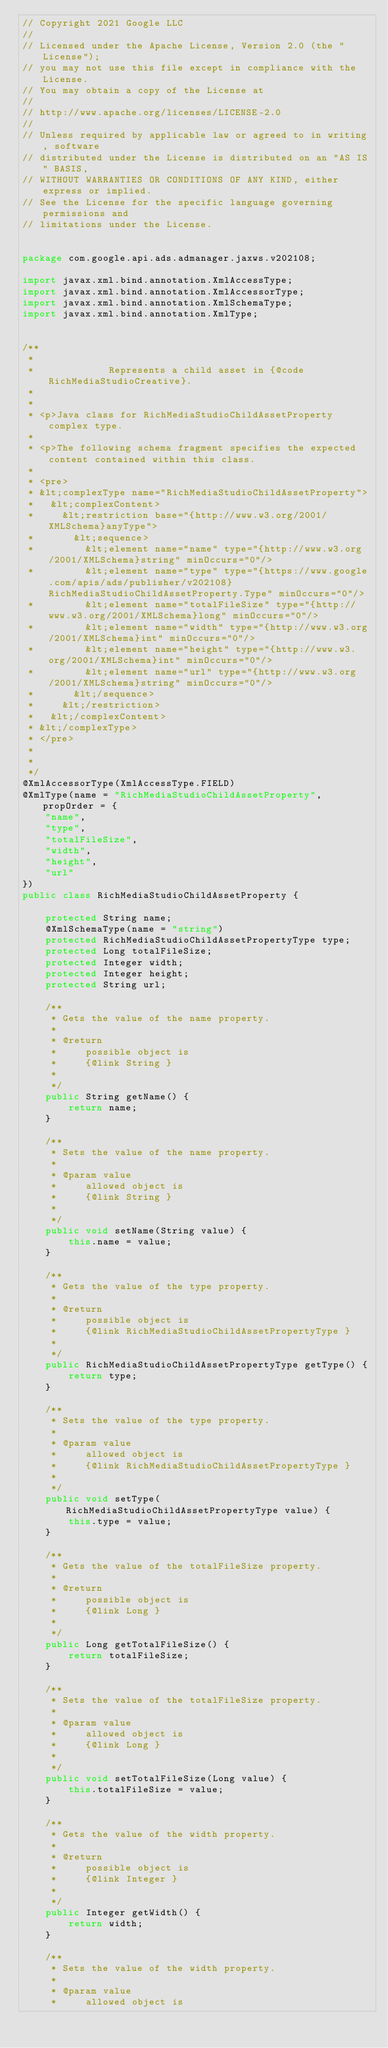Convert code to text. <code><loc_0><loc_0><loc_500><loc_500><_Java_>// Copyright 2021 Google LLC
//
// Licensed under the Apache License, Version 2.0 (the "License");
// you may not use this file except in compliance with the License.
// You may obtain a copy of the License at
//
// http://www.apache.org/licenses/LICENSE-2.0
//
// Unless required by applicable law or agreed to in writing, software
// distributed under the License is distributed on an "AS IS" BASIS,
// WITHOUT WARRANTIES OR CONDITIONS OF ANY KIND, either express or implied.
// See the License for the specific language governing permissions and
// limitations under the License.


package com.google.api.ads.admanager.jaxws.v202108;

import javax.xml.bind.annotation.XmlAccessType;
import javax.xml.bind.annotation.XmlAccessorType;
import javax.xml.bind.annotation.XmlSchemaType;
import javax.xml.bind.annotation.XmlType;


/**
 * 
 *             Represents a child asset in {@code RichMediaStudioCreative}.
 *           
 * 
 * <p>Java class for RichMediaStudioChildAssetProperty complex type.
 * 
 * <p>The following schema fragment specifies the expected content contained within this class.
 * 
 * <pre>
 * &lt;complexType name="RichMediaStudioChildAssetProperty">
 *   &lt;complexContent>
 *     &lt;restriction base="{http://www.w3.org/2001/XMLSchema}anyType">
 *       &lt;sequence>
 *         &lt;element name="name" type="{http://www.w3.org/2001/XMLSchema}string" minOccurs="0"/>
 *         &lt;element name="type" type="{https://www.google.com/apis/ads/publisher/v202108}RichMediaStudioChildAssetProperty.Type" minOccurs="0"/>
 *         &lt;element name="totalFileSize" type="{http://www.w3.org/2001/XMLSchema}long" minOccurs="0"/>
 *         &lt;element name="width" type="{http://www.w3.org/2001/XMLSchema}int" minOccurs="0"/>
 *         &lt;element name="height" type="{http://www.w3.org/2001/XMLSchema}int" minOccurs="0"/>
 *         &lt;element name="url" type="{http://www.w3.org/2001/XMLSchema}string" minOccurs="0"/>
 *       &lt;/sequence>
 *     &lt;/restriction>
 *   &lt;/complexContent>
 * &lt;/complexType>
 * </pre>
 * 
 * 
 */
@XmlAccessorType(XmlAccessType.FIELD)
@XmlType(name = "RichMediaStudioChildAssetProperty", propOrder = {
    "name",
    "type",
    "totalFileSize",
    "width",
    "height",
    "url"
})
public class RichMediaStudioChildAssetProperty {

    protected String name;
    @XmlSchemaType(name = "string")
    protected RichMediaStudioChildAssetPropertyType type;
    protected Long totalFileSize;
    protected Integer width;
    protected Integer height;
    protected String url;

    /**
     * Gets the value of the name property.
     * 
     * @return
     *     possible object is
     *     {@link String }
     *     
     */
    public String getName() {
        return name;
    }

    /**
     * Sets the value of the name property.
     * 
     * @param value
     *     allowed object is
     *     {@link String }
     *     
     */
    public void setName(String value) {
        this.name = value;
    }

    /**
     * Gets the value of the type property.
     * 
     * @return
     *     possible object is
     *     {@link RichMediaStudioChildAssetPropertyType }
     *     
     */
    public RichMediaStudioChildAssetPropertyType getType() {
        return type;
    }

    /**
     * Sets the value of the type property.
     * 
     * @param value
     *     allowed object is
     *     {@link RichMediaStudioChildAssetPropertyType }
     *     
     */
    public void setType(RichMediaStudioChildAssetPropertyType value) {
        this.type = value;
    }

    /**
     * Gets the value of the totalFileSize property.
     * 
     * @return
     *     possible object is
     *     {@link Long }
     *     
     */
    public Long getTotalFileSize() {
        return totalFileSize;
    }

    /**
     * Sets the value of the totalFileSize property.
     * 
     * @param value
     *     allowed object is
     *     {@link Long }
     *     
     */
    public void setTotalFileSize(Long value) {
        this.totalFileSize = value;
    }

    /**
     * Gets the value of the width property.
     * 
     * @return
     *     possible object is
     *     {@link Integer }
     *     
     */
    public Integer getWidth() {
        return width;
    }

    /**
     * Sets the value of the width property.
     * 
     * @param value
     *     allowed object is</code> 